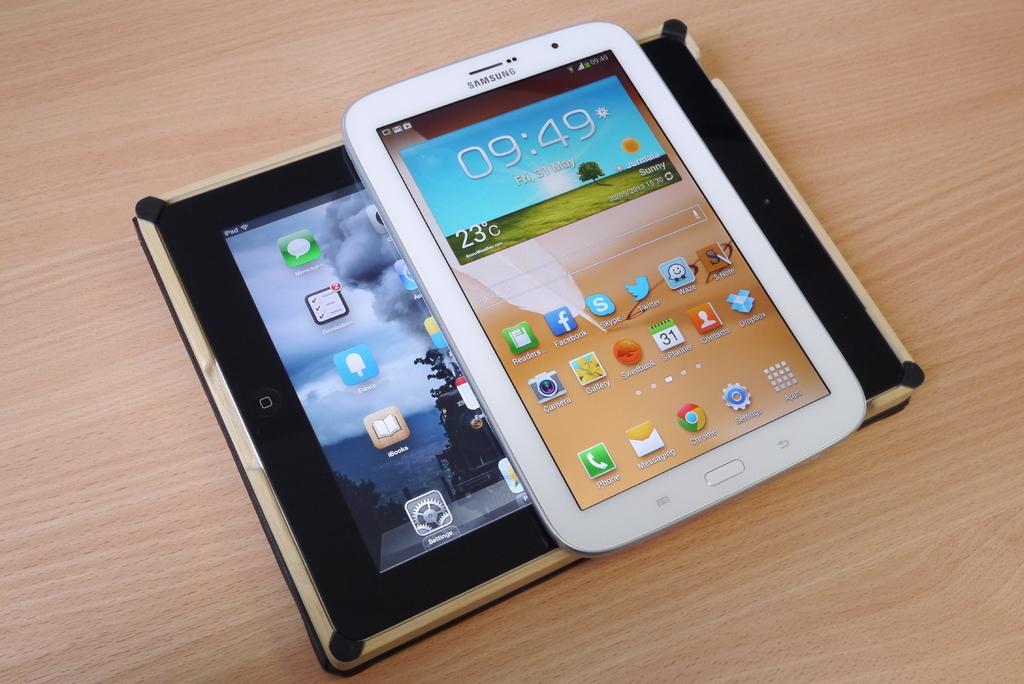Describe this image in one or two sentences. In this image we can see two devices placed on the surface. 